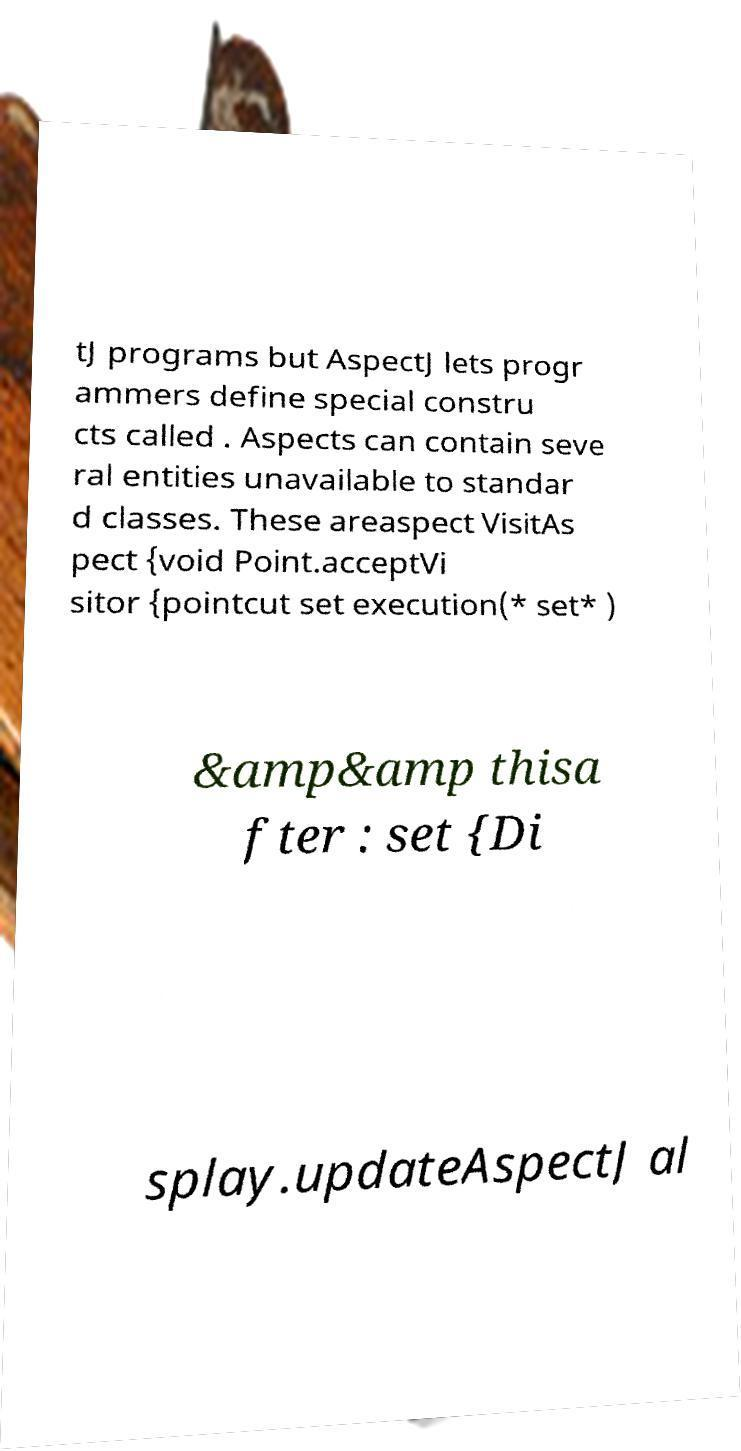There's text embedded in this image that I need extracted. Can you transcribe it verbatim? tJ programs but AspectJ lets progr ammers define special constru cts called . Aspects can contain seve ral entities unavailable to standar d classes. These areaspect VisitAs pect {void Point.acceptVi sitor {pointcut set execution(* set* ) &amp&amp thisa fter : set {Di splay.updateAspectJ al 